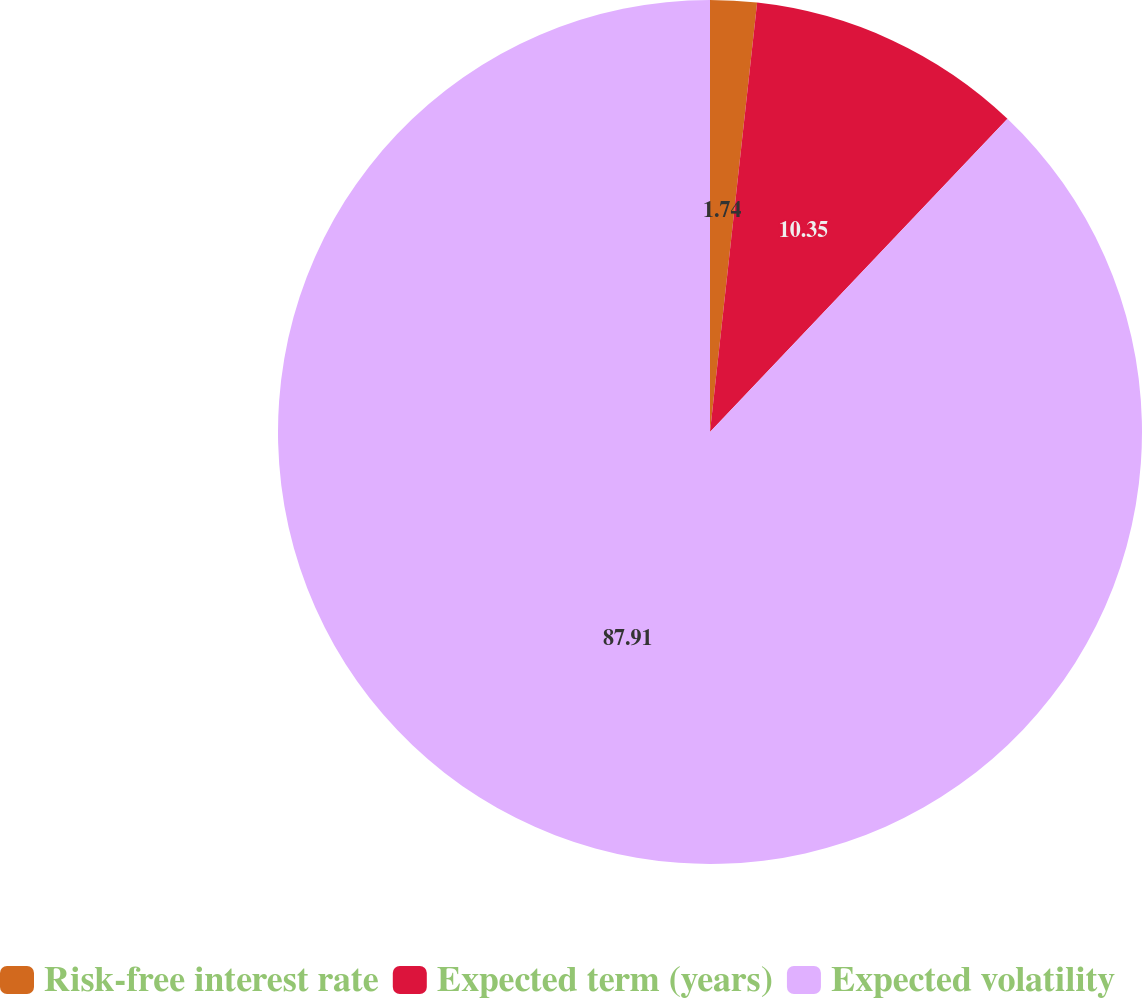Convert chart to OTSL. <chart><loc_0><loc_0><loc_500><loc_500><pie_chart><fcel>Risk-free interest rate<fcel>Expected term (years)<fcel>Expected volatility<nl><fcel>1.74%<fcel>10.35%<fcel>87.92%<nl></chart> 